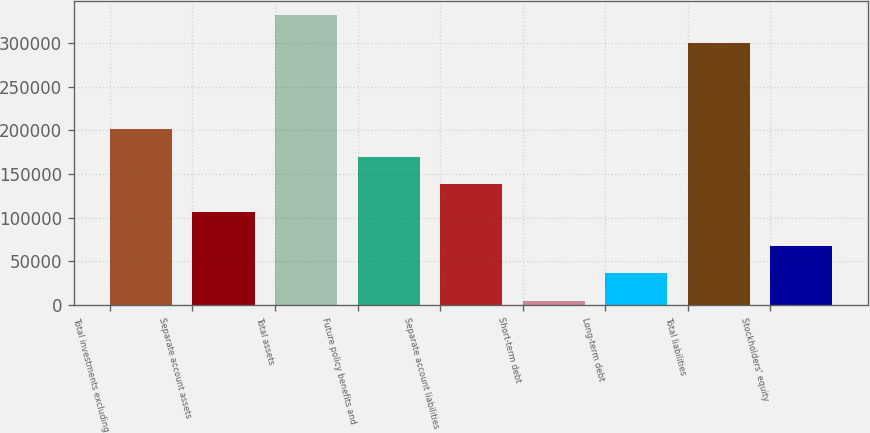Convert chart. <chart><loc_0><loc_0><loc_500><loc_500><bar_chart><fcel>Total investments excluding<fcel>Separate account assets<fcel>Total assets<fcel>Future policy benefits and<fcel>Separate account liabilities<fcel>Short-term debt<fcel>Long-term debt<fcel>Total liabilities<fcel>Stockholders' equity<nl><fcel>201640<fcel>106680<fcel>331636<fcel>169987<fcel>138334<fcel>4739<fcel>36392.5<fcel>299982<fcel>68046<nl></chart> 